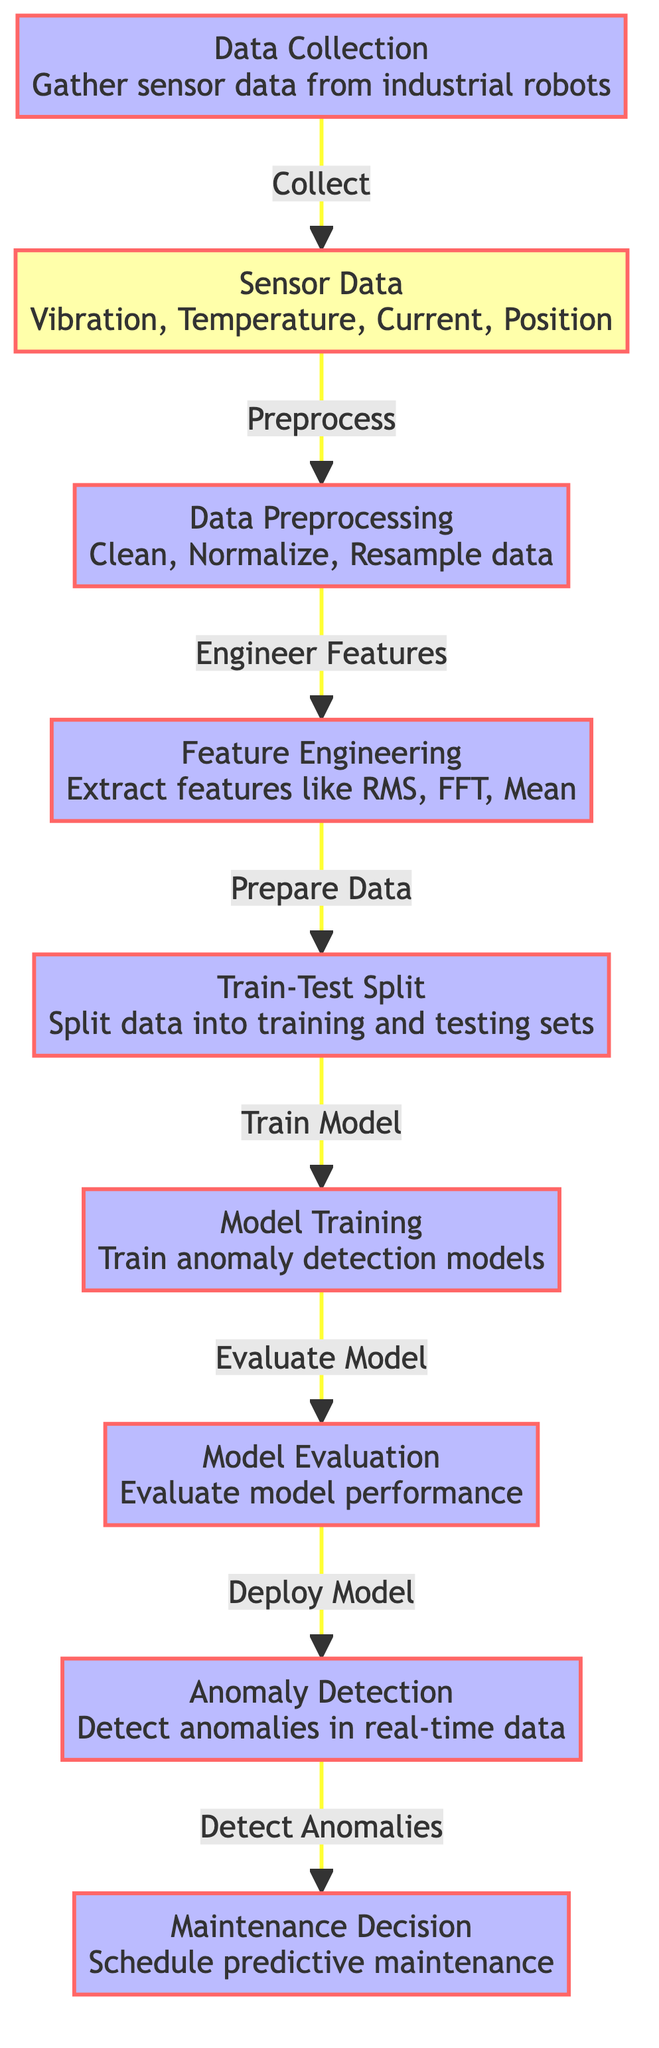What is the first step in the predictive maintenance process? The diagram indicates that the first step is "Data Collection," which involves gathering sensor data from industrial robots.
Answer: Data Collection How many types of sensor data are mentioned in the diagram? In the diagram, four types of sensor data are listed: Vibration, Temperature, Current, and Position.
Answer: Four What is the output of the "Model Evaluation" step? The "Model Evaluation" step leads to the "Deploy Model" step, indicating that the output is the readiness and assessment of the model for deployment.
Answer: Deploy Model Which step follows "Feature Engineering"? The diagram shows that the "Train-Test Split" step follows "Feature Engineering," indicating the transition from feature extraction to data preparation.
Answer: Train-Test Split What role does the "Anomaly Detection" step play in the overall process? The "Anomaly Detection" step detects anomalies in real-time data, which is crucial for identifying issues in the operation of industrial robots.
Answer: Detect anomalies How many processes are involved in the predictive maintenance workflow? The diagram consists of six distinct process nodes: Data Collection, Data Preprocessing, Feature Engineering, Train-Test Split, Model Training, Model Evaluation, Anomaly Detection, and Maintenance Decision.
Answer: Six What is the relationship between "Model Training" and "Model Evaluation"? The relationship is sequential; after "Model Training," the next step indicated in the diagram is "Model Evaluation," which assesses the model's performance.
Answer: Assess performance What is the purpose of "Maintenance Decision"? The purpose of "Maintenance Decision" is to schedule predictive maintenance based on the results of the anomaly detection process to prevent failures.
Answer: Schedule predictive maintenance 